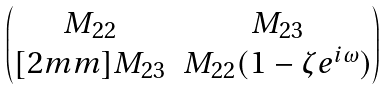Convert formula to latex. <formula><loc_0><loc_0><loc_500><loc_500>\begin{pmatrix} M _ { 2 2 } & M _ { 2 3 } \\ [ 2 m m ] M _ { 2 3 } & M _ { 2 2 } ( 1 - \zeta e ^ { i \omega } ) \end{pmatrix}</formula> 